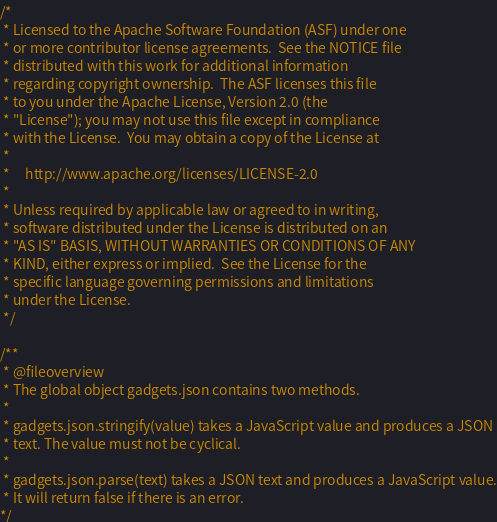Convert code to text. <code><loc_0><loc_0><loc_500><loc_500><_JavaScript_>/*
 * Licensed to the Apache Software Foundation (ASF) under one
 * or more contributor license agreements.  See the NOTICE file
 * distributed with this work for additional information
 * regarding copyright ownership.  The ASF licenses this file
 * to you under the Apache License, Version 2.0 (the
 * "License"); you may not use this file except in compliance
 * with the License.  You may obtain a copy of the License at
 *
 *     http://www.apache.org/licenses/LICENSE-2.0
 *
 * Unless required by applicable law or agreed to in writing,
 * software distributed under the License is distributed on an
 * "AS IS" BASIS, WITHOUT WARRANTIES OR CONDITIONS OF ANY
 * KIND, either express or implied.  See the License for the
 * specific language governing permissions and limitations
 * under the License.
 */

/**
 * @fileoverview
 * The global object gadgets.json contains two methods.
 *
 * gadgets.json.stringify(value) takes a JavaScript value and produces a JSON
 * text. The value must not be cyclical.
 *
 * gadgets.json.parse(text) takes a JSON text and produces a JavaScript value.
 * It will return false if there is an error.
*/
</code> 